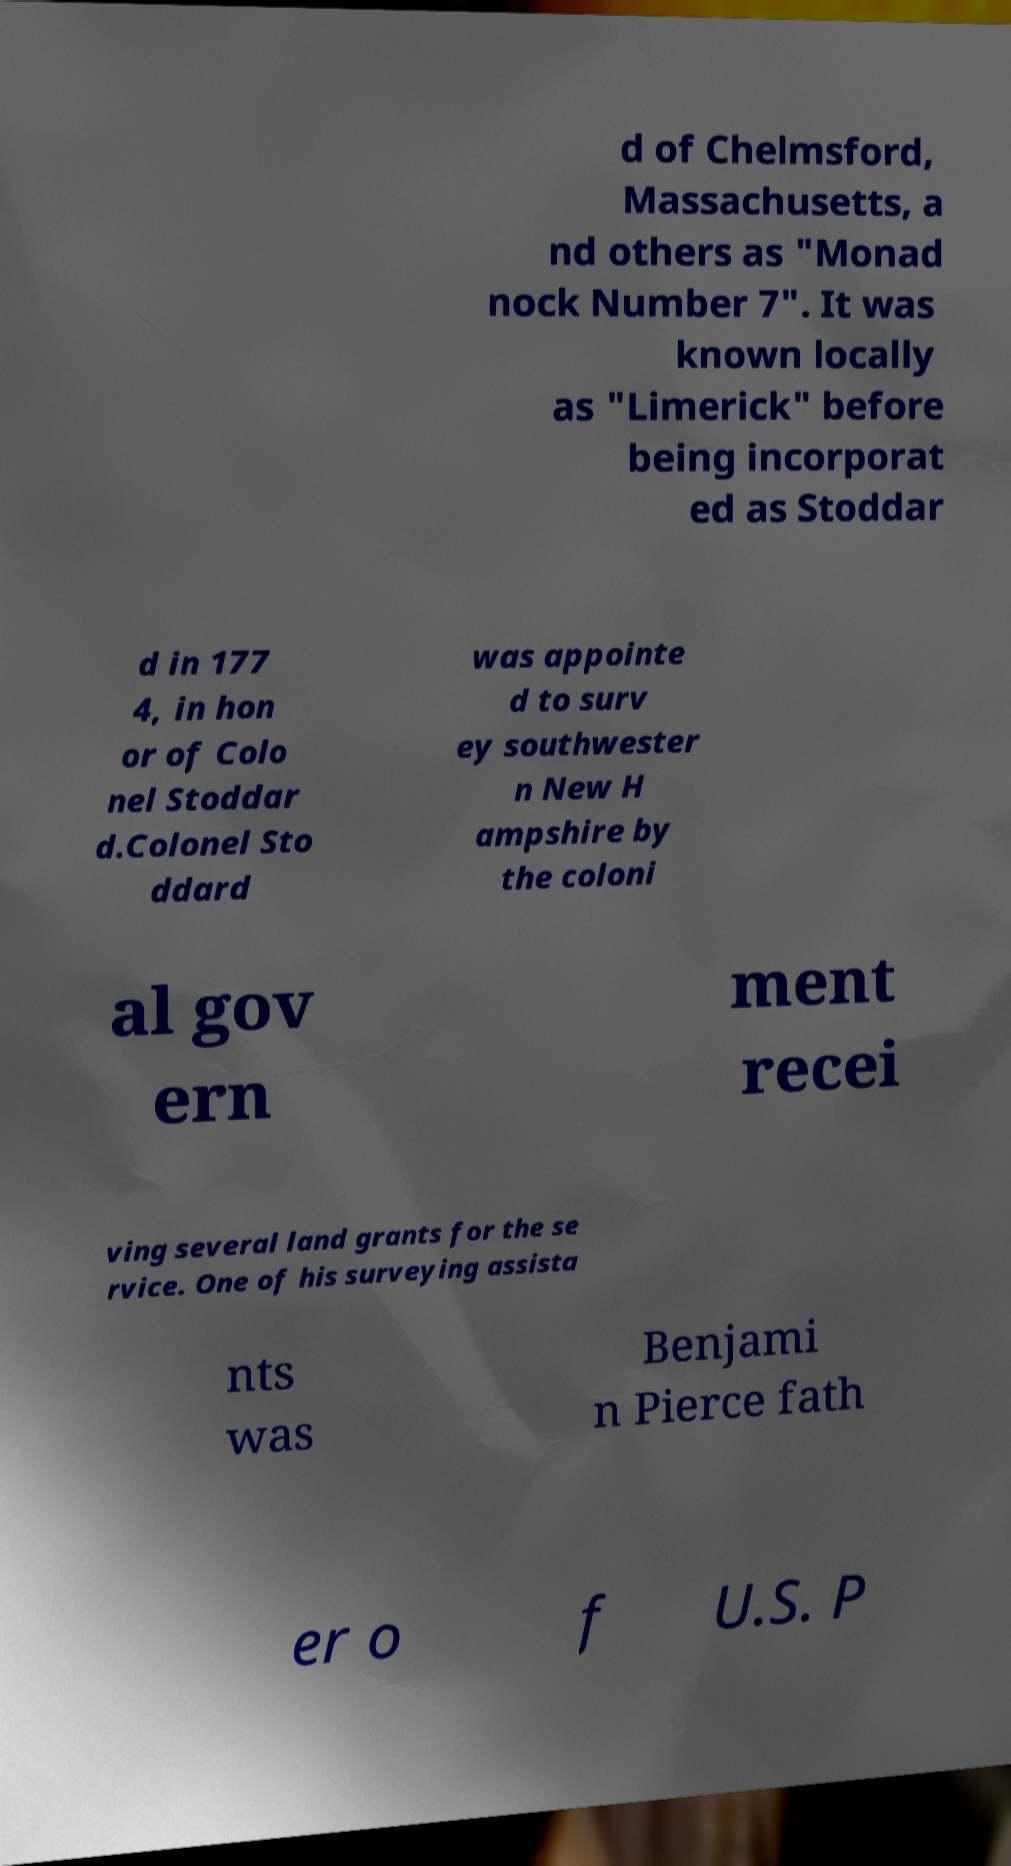Can you accurately transcribe the text from the provided image for me? d of Chelmsford, Massachusetts, a nd others as "Monad nock Number 7". It was known locally as "Limerick" before being incorporat ed as Stoddar d in 177 4, in hon or of Colo nel Stoddar d.Colonel Sto ddard was appointe d to surv ey southwester n New H ampshire by the coloni al gov ern ment recei ving several land grants for the se rvice. One of his surveying assista nts was Benjami n Pierce fath er o f U.S. P 